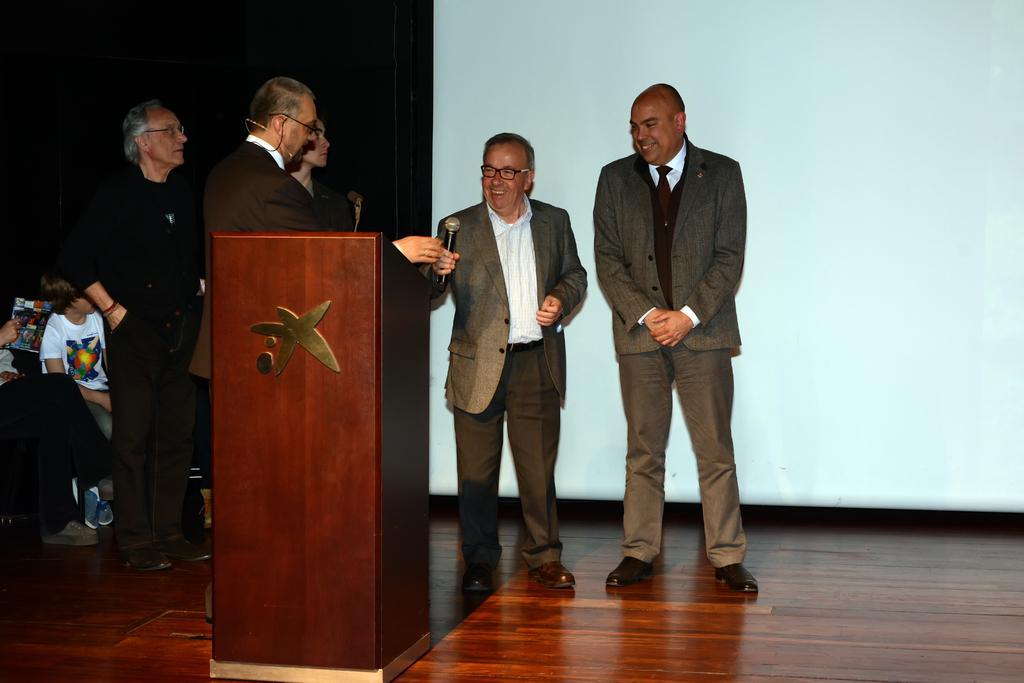Could you give a brief overview of what you see in this image? In this picture there is a man who is wearing blazer, shirt, ear mic, spectacle and trouser. He is standing near to the speech desk. On the right there are two persons standing near to the projector screen. On the left we can see group of person sitting on the chair. On the top left we can see darkness. 